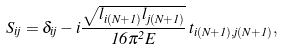Convert formula to latex. <formula><loc_0><loc_0><loc_500><loc_500>S _ { i j } = \delta _ { i j } - i \frac { \sqrt { l _ { i ( N + 1 ) } l _ { j ( N + 1 ) } } } { 1 6 \pi ^ { 2 } E } \, t _ { i ( N + 1 ) , j ( N + 1 ) } ,</formula> 